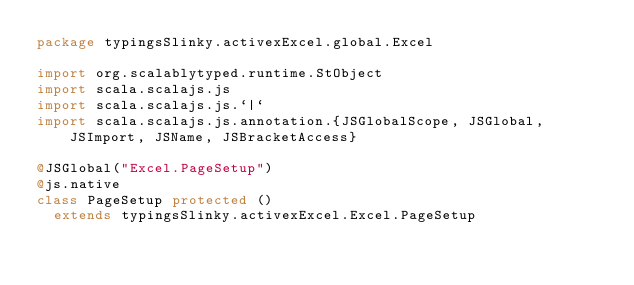Convert code to text. <code><loc_0><loc_0><loc_500><loc_500><_Scala_>package typingsSlinky.activexExcel.global.Excel

import org.scalablytyped.runtime.StObject
import scala.scalajs.js
import scala.scalajs.js.`|`
import scala.scalajs.js.annotation.{JSGlobalScope, JSGlobal, JSImport, JSName, JSBracketAccess}

@JSGlobal("Excel.PageSetup")
@js.native
class PageSetup protected ()
  extends typingsSlinky.activexExcel.Excel.PageSetup
</code> 